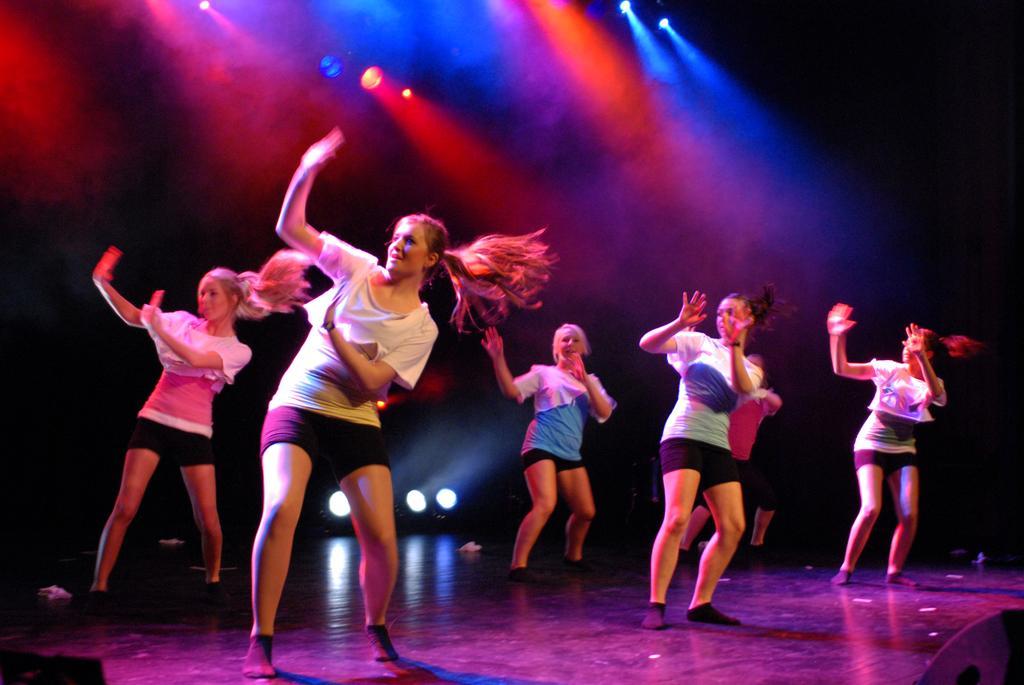Can you describe this image briefly? In this image I can see a group of girls are dancing, at the top there are focus lights. 